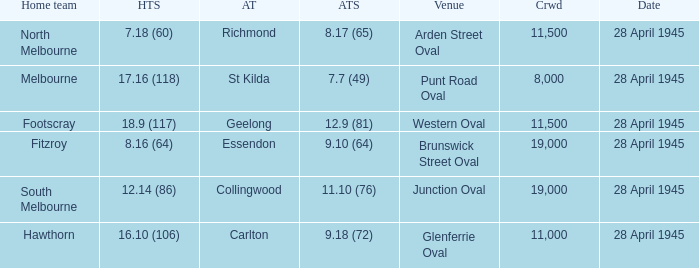Which away team has a Home team score of 12.14 (86)? 11.10 (76). 